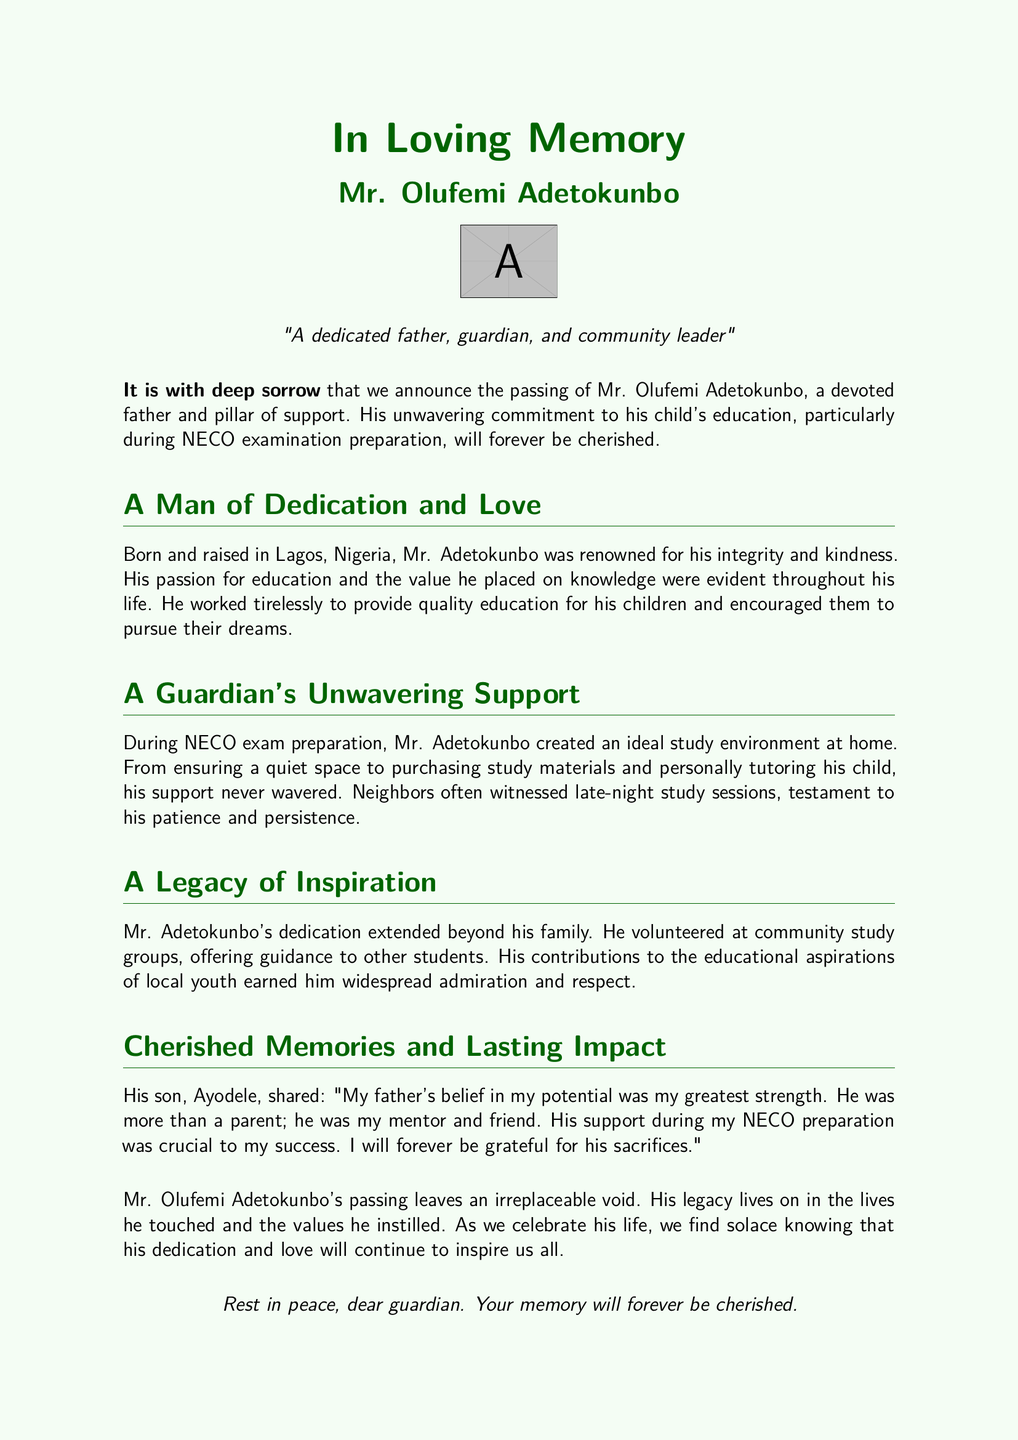What is the full name of the deceased? The full name provided in the obituary is Mr. Olufemi Adetokunbo.
Answer: Mr. Olufemi Adetokunbo What is the cause for the announcement? The document announces the passing of Mr. Olufemi Adetokunbo, indicating a loss to the family and community.
Answer: Passing of Mr. Olufemi Adetokunbo Who does Ayodele refer to Mr. Adetokunbo as in his tribute? Ayodele describes Mr. Adetokunbo as a mentor and friend, highlighting the close relationship they had.
Answer: Mentor and friend What role did Mr. Adetokunbo play during NECO preparation? Mr. Adetokunbo provided support by creating a conducive study environment and tutoring his child, exemplifying his involvement in the academic process.
Answer: Guardian's support What characteristic is Mr. Adetokunbo known for in his community? He is renowned for his integrity and kindness, as mentioned in the document.
Answer: Integrity and kindness How did Mr. Adetokunbo contribute to the community? He volunteered at community study groups, providing guidance to students and enhancing educational aspirations.
Answer: Volunteered at community study groups What emotion is expressed regarding Mr. Adetokunbo's passing? The document expresses deep sorrow over the loss of Mr. Adetokunbo, emphasizing the void left behind.
Answer: Deep sorrow What is the message at the end of the obituary? The farewell message expresses a wish for Mr. Adetokunbo to rest in peace and acknowledges the lasting impact of his memory.
Answer: Rest in peace, dear guardian 